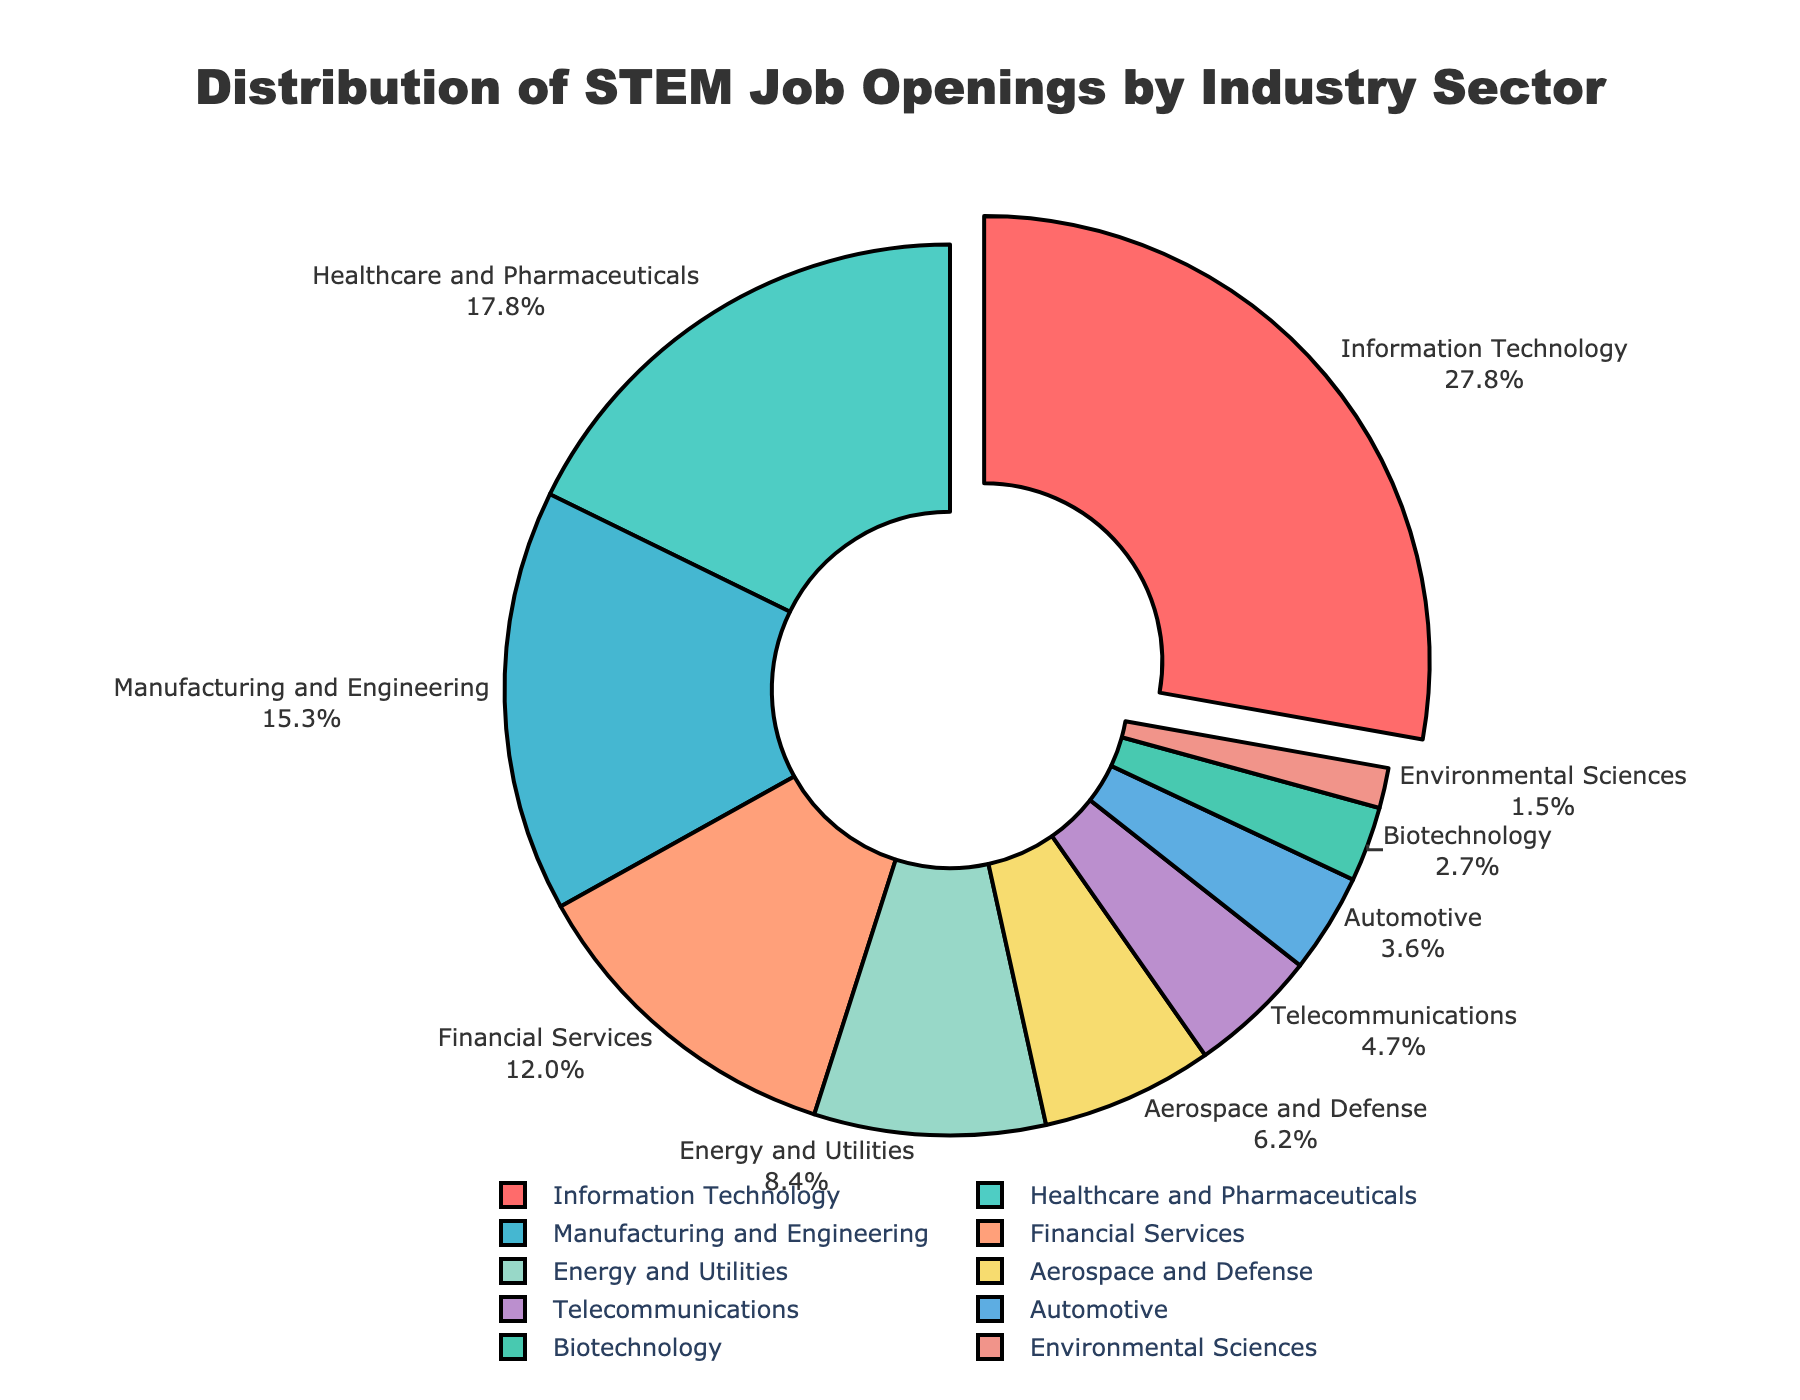What's the largest percentage of job openings in any sector? The largest percentage can be found by looking for the segment of the pie chart that takes up the most space. The "Information Technology" sector has the largest share.
Answer: 28.5% Which sectors together make up more than half of the STEM job openings? To determine which sectors together account for more than 50%, sum the highest percentages until over 50% is reached: Information Technology (28.5%) + Healthcare and Pharmaceuticals (18.2%) = 46.7%, and adding Manufacturing and Engineering (15.7%) brings the total to 62.4%.
Answer: Information Technology, Healthcare and Pharmaceuticals, Manufacturing and Engineering Which sector has the smallest percentage of job openings, and what is that percentage? The smallest segment in the pie chart is the one that represents "Environmental Sciences."
Answer: Environmental Sciences, 1.5% What is the total percentage of job openings in the Financial Services, Energy and Utilities, and Aerospace and Defense sectors? Add the percentages of the given sectors: Financial Services (12.3%) + Energy and Utilities (8.6%) + Aerospace and Defense (6.4%) = 27.3%.
Answer: 27.3% How many sectors have a percentage of job openings greater than 10%? By inspecting each sector on the pie chart, it can be determined that the sectors with more than 10% are: Information Technology (28.5%), Healthcare and Pharmaceuticals (18.2%), Manufacturing and Engineering (15.7%), and Financial Services (12.3%). There are 4 such sectors.
Answer: 4 Compare the percentage of job openings in the Healthcare and Pharmaceuticals sector to the Telecommunications sector. Which one is larger and by how much? The Healthcare and Pharmaceuticals sector has 18.2%, and the Telecommunications sector has 4.8%. The difference is 18.2% - 4.8% = 13.4%. The Healthcare and Pharmaceuticals sector is larger by 13.4%.
Answer: Healthcare and Pharmaceuticals, 13.4% If you combine the percentages of the Biotechnology and Environmental Sciences sectors, do they exceed the percentage of the Aerospace and Defense sector? The sum of Biotechnology (2.8%) and Environmental Sciences (1.5%) is 2.8% + 1.5% = 4.3%. This is less than Aerospace and Defense's 6.4%. So, they do not exceed it.
Answer: No What is the difference in percentage points between the Information Technology sector and the Energy and Utilities sector? Subtract the percentage of Energy and Utilities (8.6%) from that of Information Technology (28.5%): 28.5% - 8.6% = 19.9 percentage points.
Answer: 19.9 Which sector's slice is colored green? By referring to the color scheme in the provided data and visual chart, the Healthcare and Pharmaceuticals sector is represented by the green color.
Answer: Healthcare and Pharmaceuticals 